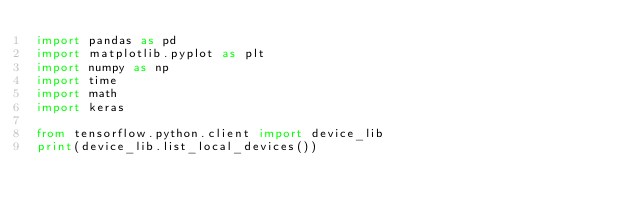Convert code to text. <code><loc_0><loc_0><loc_500><loc_500><_Python_>import pandas as pd
import matplotlib.pyplot as plt
import numpy as np
import time
import math
import keras

from tensorflow.python.client import device_lib
print(device_lib.list_local_devices())
</code> 